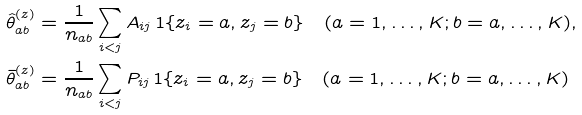Convert formula to latex. <formula><loc_0><loc_0><loc_500><loc_500>\hat { \theta } _ { a b } ^ { ( z ) } & = \frac { 1 } { n _ { a b } } \sum _ { i < j } A _ { i j } \, 1 \{ z _ { i } = a , z _ { j } = b \} \quad ( a = 1 , \dots , K ; b = a , \dots , K ) , \\ \bar { \theta } _ { a b } ^ { ( z ) } & = \frac { 1 } { n _ { a b } } \sum _ { i < j } P _ { i j } \, 1 \{ z _ { i } = a , z _ { j } = b \} \quad ( a = 1 , \dots , K ; b = a , \dots , K )</formula> 